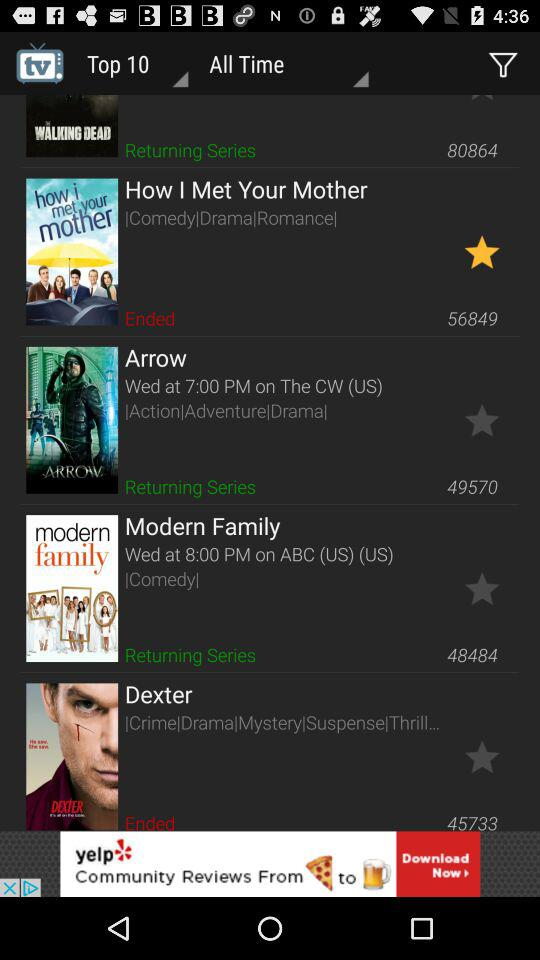How many of the shows are returning series?
Answer the question using a single word or phrase. 3 